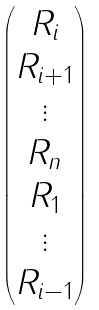<formula> <loc_0><loc_0><loc_500><loc_500>\begin{pmatrix} R _ { i } \\ R _ { i + 1 } \\ \vdots \\ R _ { n } \\ R _ { 1 } \\ \vdots \\ R _ { i - 1 } \end{pmatrix}</formula> 